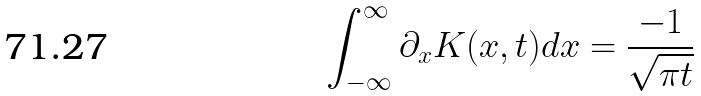Convert formula to latex. <formula><loc_0><loc_0><loc_500><loc_500>\int _ { - \infty } ^ { \infty } \partial _ { x } K ( x , t ) d x = \frac { - 1 } { \sqrt { \pi t } }</formula> 